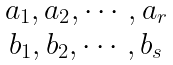Convert formula to latex. <formula><loc_0><loc_0><loc_500><loc_500>\begin{matrix} a _ { 1 } , a _ { 2 } , \cdots , a _ { r } \\ b _ { 1 } , b _ { 2 } , \cdots , b _ { s } \end{matrix}</formula> 